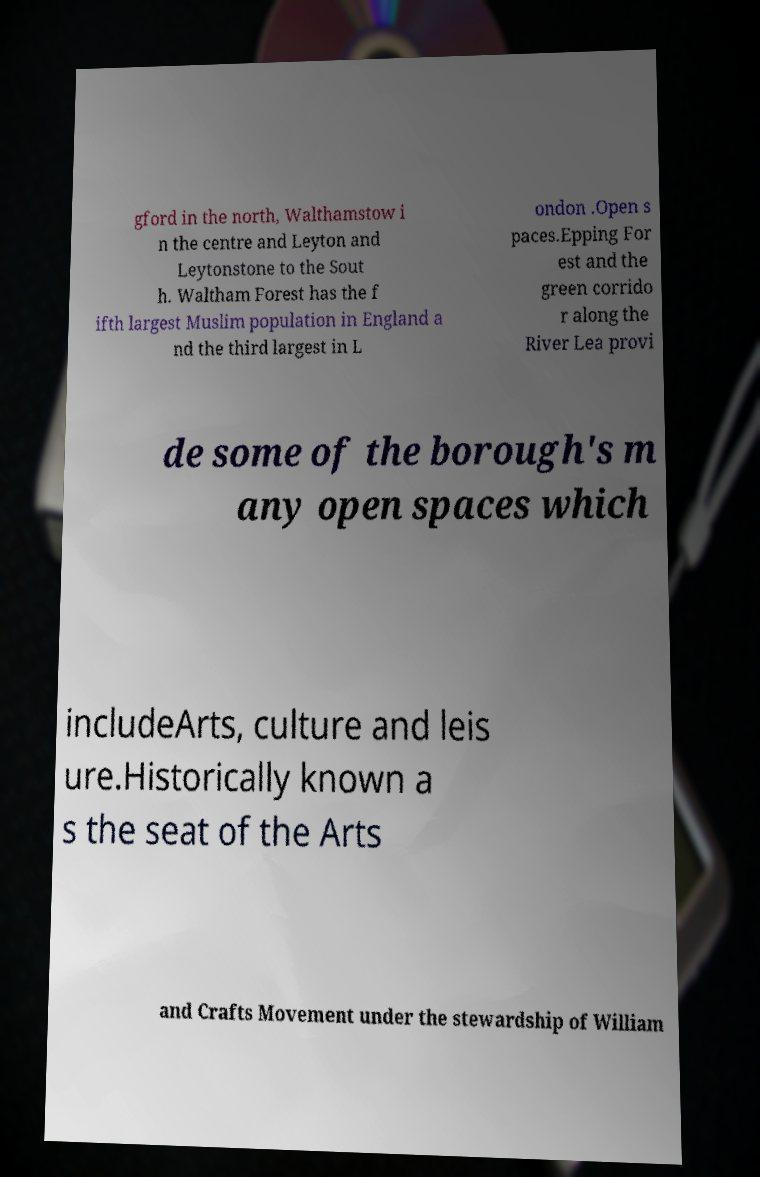Can you accurately transcribe the text from the provided image for me? gford in the north, Walthamstow i n the centre and Leyton and Leytonstone to the Sout h. Waltham Forest has the f ifth largest Muslim population in England a nd the third largest in L ondon .Open s paces.Epping For est and the green corrido r along the River Lea provi de some of the borough's m any open spaces which includeArts, culture and leis ure.Historically known a s the seat of the Arts and Crafts Movement under the stewardship of William 